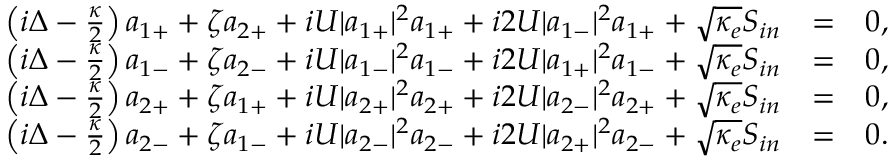Convert formula to latex. <formula><loc_0><loc_0><loc_500><loc_500>\begin{array} { r l r } { \left ( i \Delta - \frac { \kappa } { 2 } \right ) a _ { 1 + } + \zeta a _ { 2 + } + i U | a _ { 1 + } | ^ { 2 } a _ { 1 + } + i 2 U | a _ { 1 - } | ^ { 2 } a _ { 1 + } + \sqrt { \kappa _ { e } } S _ { i n } } & { = } & { 0 , } \\ { \left ( i \Delta - \frac { \kappa } { 2 } \right ) a _ { 1 - } + \zeta a _ { 2 - } + i U | a _ { 1 - } | ^ { 2 } a _ { 1 - } + i 2 U | a _ { 1 + } | ^ { 2 } a _ { 1 - } + \sqrt { \kappa _ { e } } S _ { i n } } & { = } & { 0 , } \\ { \left ( i \Delta - \frac { \kappa } { 2 } \right ) a _ { 2 + } + \zeta a _ { 1 + } + i U | a _ { 2 + } | ^ { 2 } a _ { 2 + } + i 2 U | a _ { 2 - } | ^ { 2 } a _ { 2 + } + \sqrt { \kappa _ { e } } S _ { i n } } & { = } & { 0 , } \\ { \left ( i \Delta - \frac { \kappa } { 2 } \right ) a _ { 2 - } + \zeta a _ { 1 - } + i U | a _ { 2 - } | ^ { 2 } a _ { 2 - } + i 2 U | a _ { 2 + } | ^ { 2 } a _ { 2 - } + \sqrt { \kappa _ { e } } S _ { i n } } & { = } & { 0 . } \end{array}</formula> 